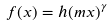<formula> <loc_0><loc_0><loc_500><loc_500>f ( x ) = h ( m x ) ^ { \gamma }</formula> 